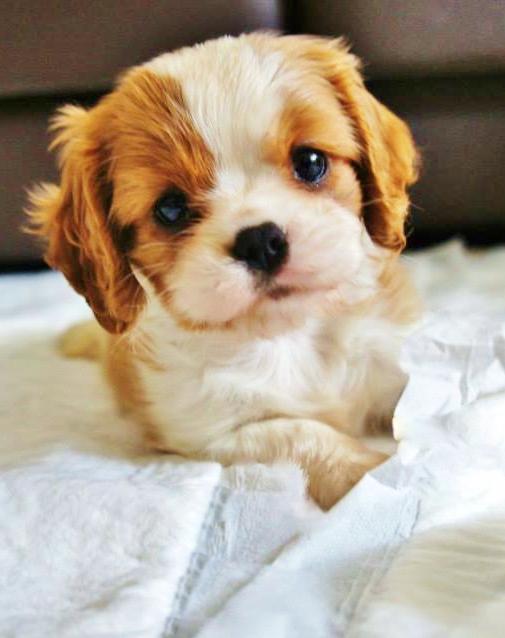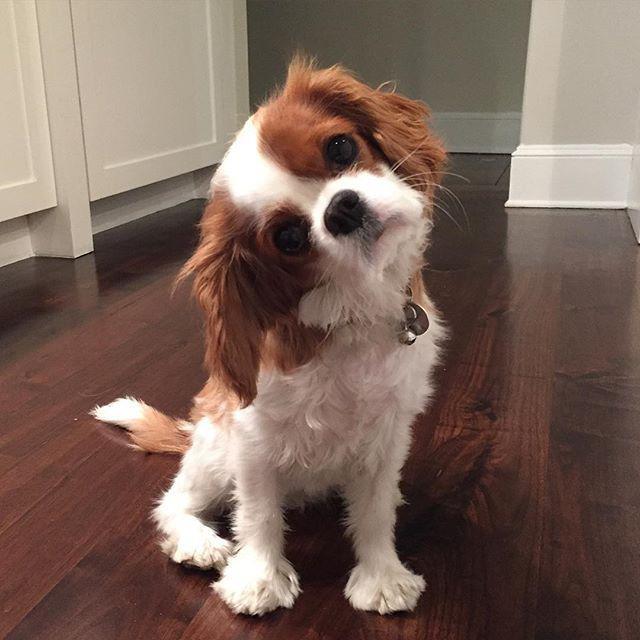The first image is the image on the left, the second image is the image on the right. Given the left and right images, does the statement "A brown and white puppy has its head cocked to the left." hold true? Answer yes or no. Yes. The first image is the image on the left, the second image is the image on the right. For the images displayed, is the sentence "There is a total of 1 collar on a small dog." factually correct? Answer yes or no. Yes. 